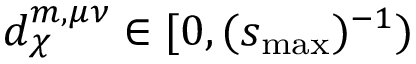Convert formula to latex. <formula><loc_0><loc_0><loc_500><loc_500>d _ { \chi } ^ { m , \mu \nu } \in [ 0 , ( s _ { \max } ) ^ { - 1 } )</formula> 